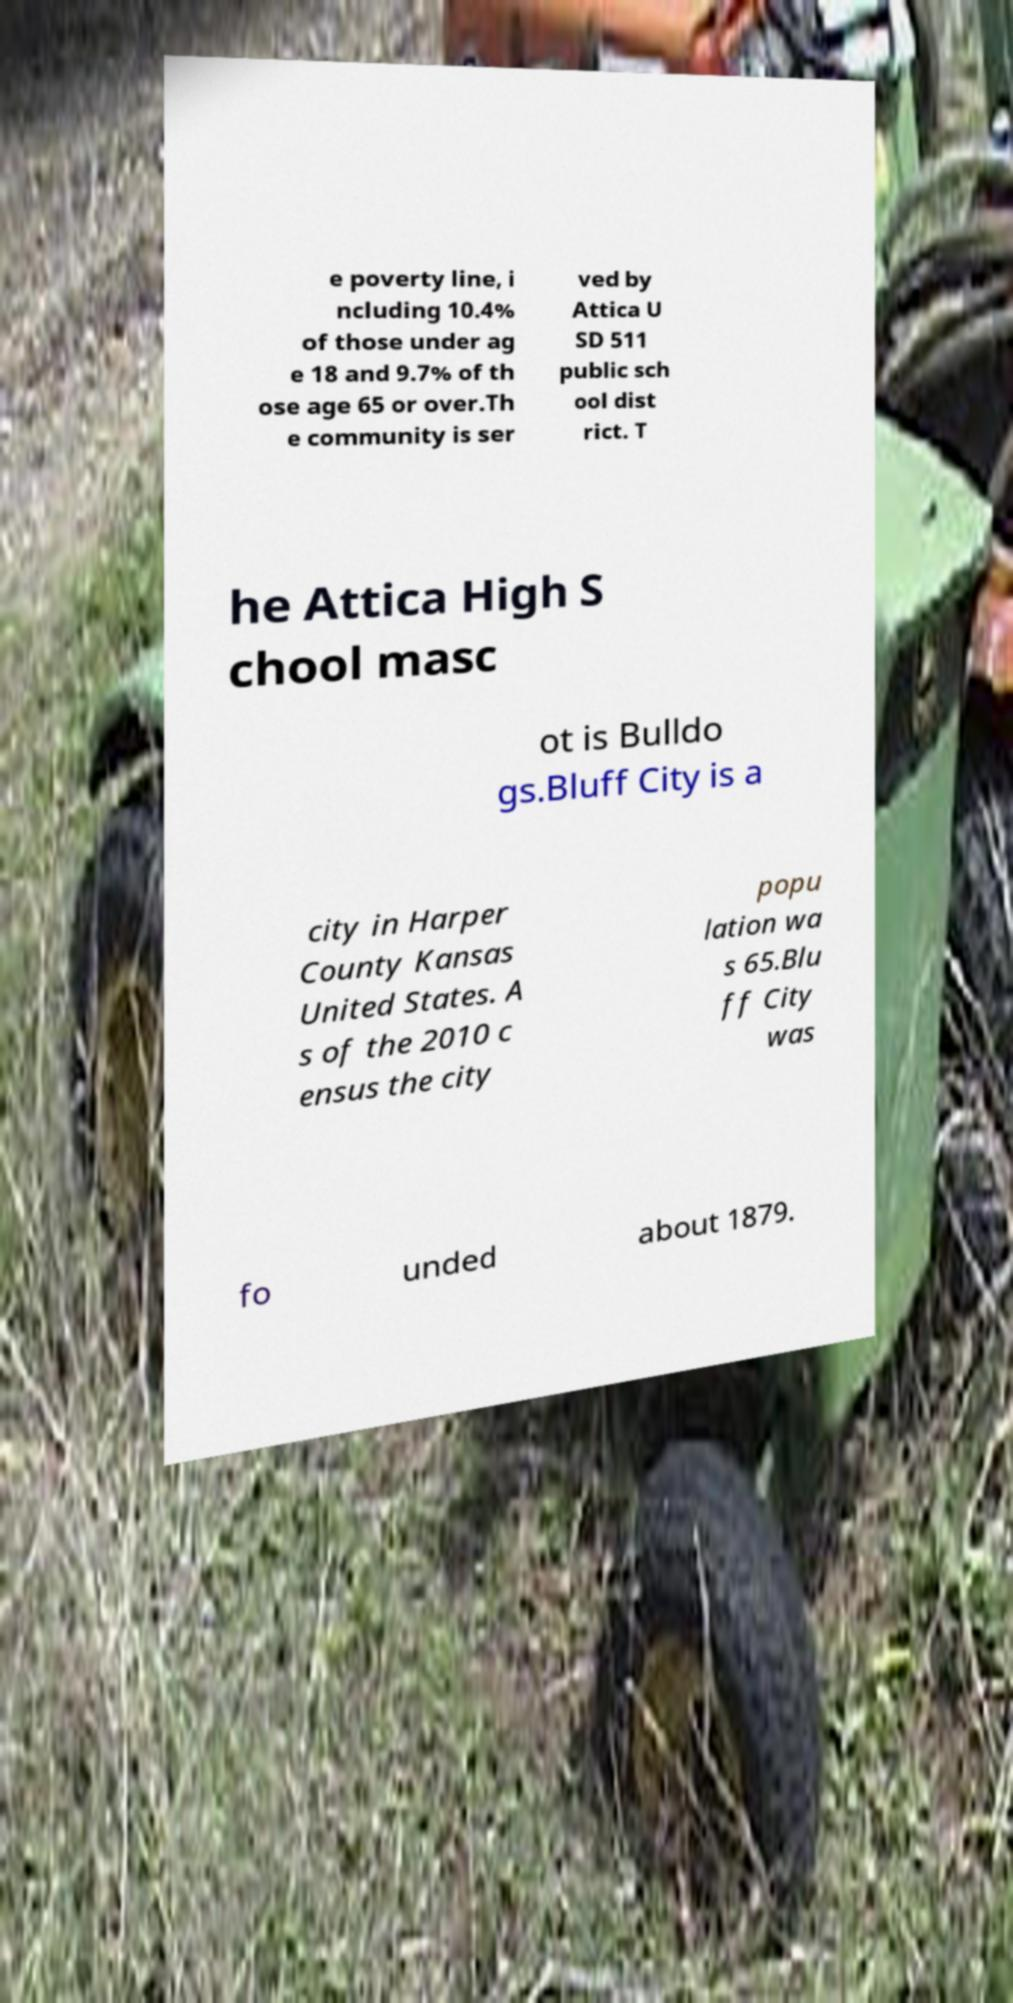I need the written content from this picture converted into text. Can you do that? e poverty line, i ncluding 10.4% of those under ag e 18 and 9.7% of th ose age 65 or over.Th e community is ser ved by Attica U SD 511 public sch ool dist rict. T he Attica High S chool masc ot is Bulldo gs.Bluff City is a city in Harper County Kansas United States. A s of the 2010 c ensus the city popu lation wa s 65.Blu ff City was fo unded about 1879. 